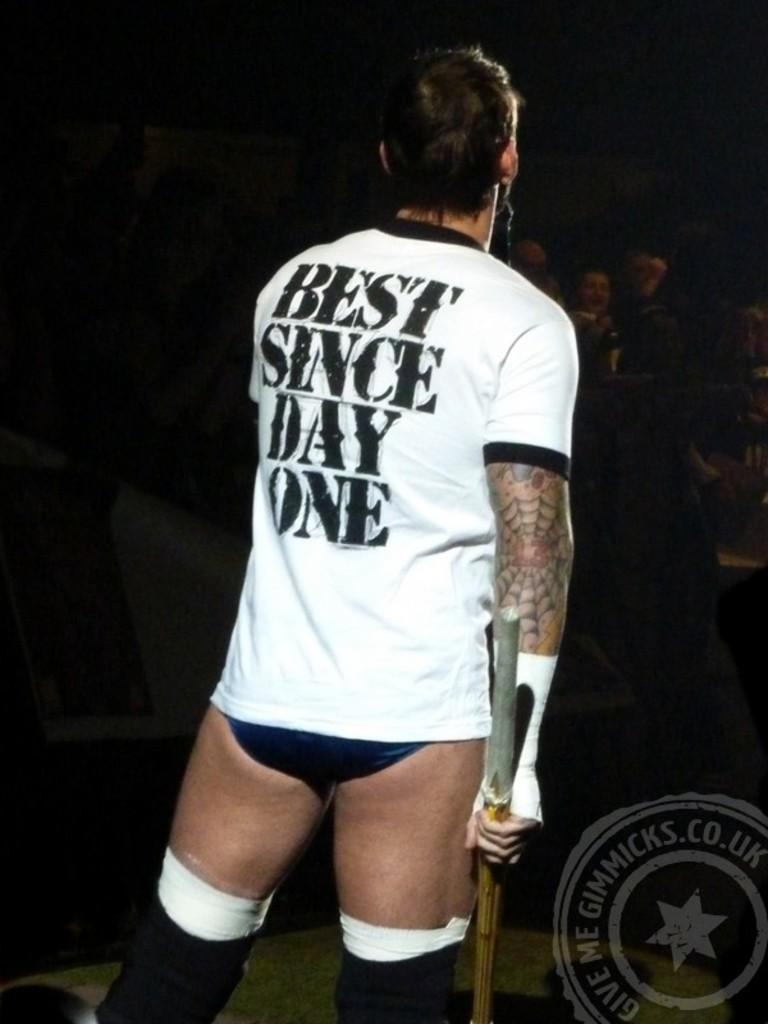<image>
Describe the image concisely. A man wears a shirt that has the phrase best since day one on the back. 